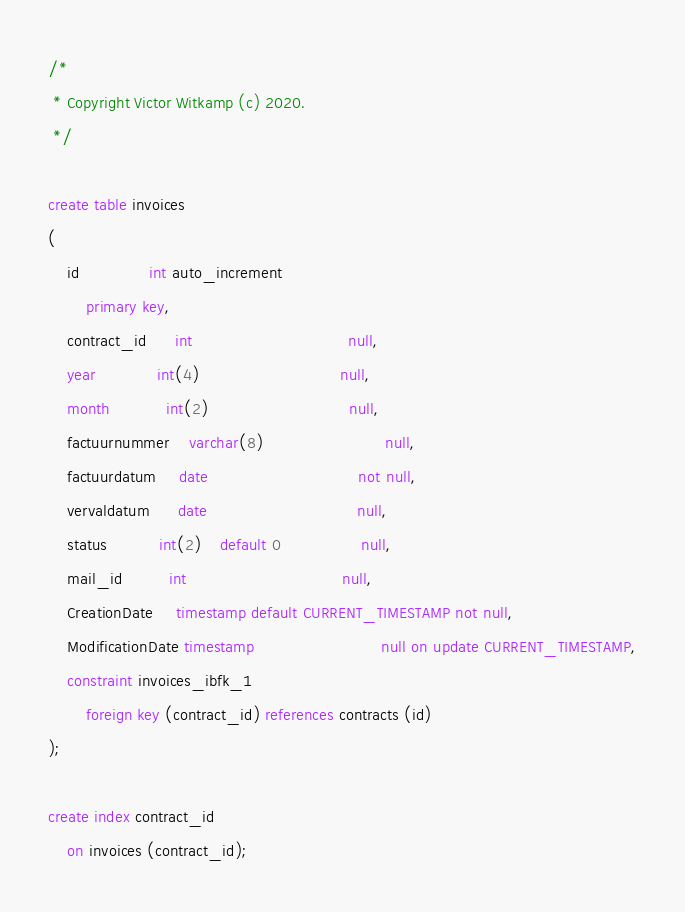<code> <loc_0><loc_0><loc_500><loc_500><_SQL_>/*
 * Copyright Victor Witkamp (c) 2020.
 */

create table invoices
(
    id               int auto_increment
        primary key,
    contract_id      int                                 null,
    year             int(4)                              null,
    month            int(2)                              null,
    factuurnummer    varchar(8)                          null,
    factuurdatum     date                                not null,
    vervaldatum      date                                null,
    status           int(2)    default 0                 null,
    mail_id          int                                 null,
    CreationDate     timestamp default CURRENT_TIMESTAMP not null,
    ModificationDate timestamp                           null on update CURRENT_TIMESTAMP,
    constraint invoices_ibfk_1
        foreign key (contract_id) references contracts (id)
);

create index contract_id
    on invoices (contract_id);

</code> 